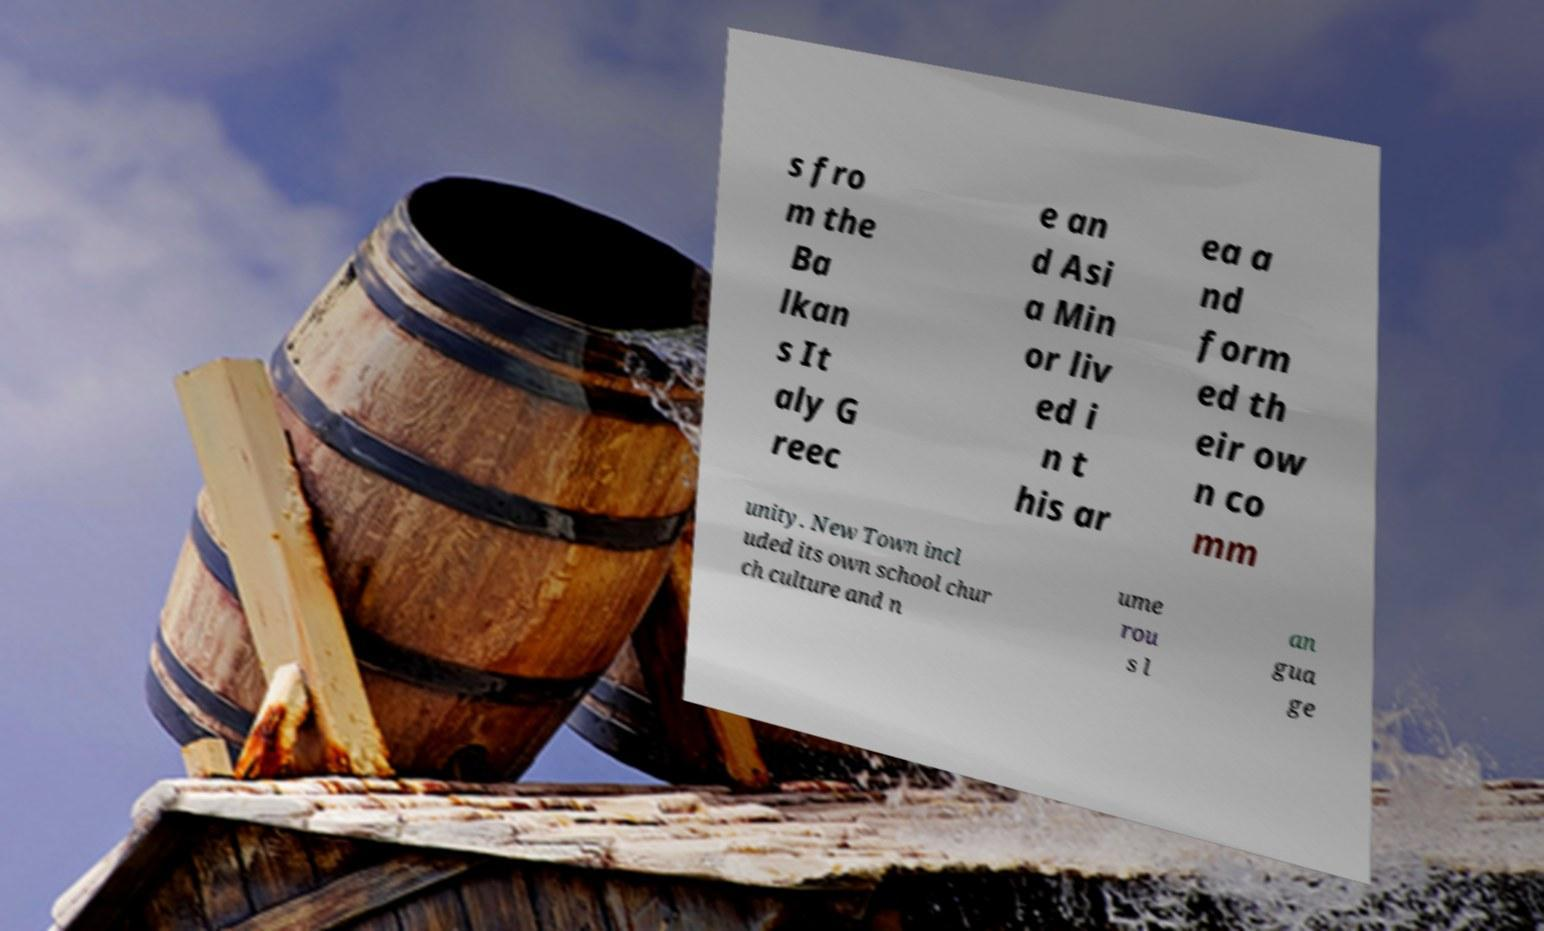Can you read and provide the text displayed in the image?This photo seems to have some interesting text. Can you extract and type it out for me? s fro m the Ba lkan s It aly G reec e an d Asi a Min or liv ed i n t his ar ea a nd form ed th eir ow n co mm unity. New Town incl uded its own school chur ch culture and n ume rou s l an gua ge 